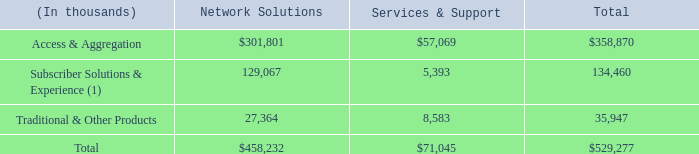The following table disaggregates our revenue by major source for the year ended December 31, 2018:
(1) Subscriber Solutions & Experience was formerly reported as Customer Devices. With the increasing focus on enhancing the customer experience for both our business and consumer broadband customers and the addition of SmartRG during the fourth quarter of 2018, Subscriber Solutions & Experience more accurately represents this revenue category.
What does the table show? Disaggregates our revenue by major source for the year ended december 31, 2018. What was the revenue from Access & Aggregation for Network Solutions?
Answer scale should be: thousand. $301,801. What was the total revenue from Network Solutions?
Answer scale should be: thousand. $458,232. What was the difference between the total revenue from Network Solutions and Services & Support?
Answer scale should be: thousand. $458,232-$71,045
Answer: 387187. What was the difference between the total revenue from Subscriber Solutions & Experience and Traditional & Other Products?
Answer scale should be: thousand. 134,460-35,947
Answer: 98513. What was the total revenue from traditional & other products as a percentage of total revenue from all sources?
Answer scale should be: percent. 35,947/$529,277
Answer: 6.79. 